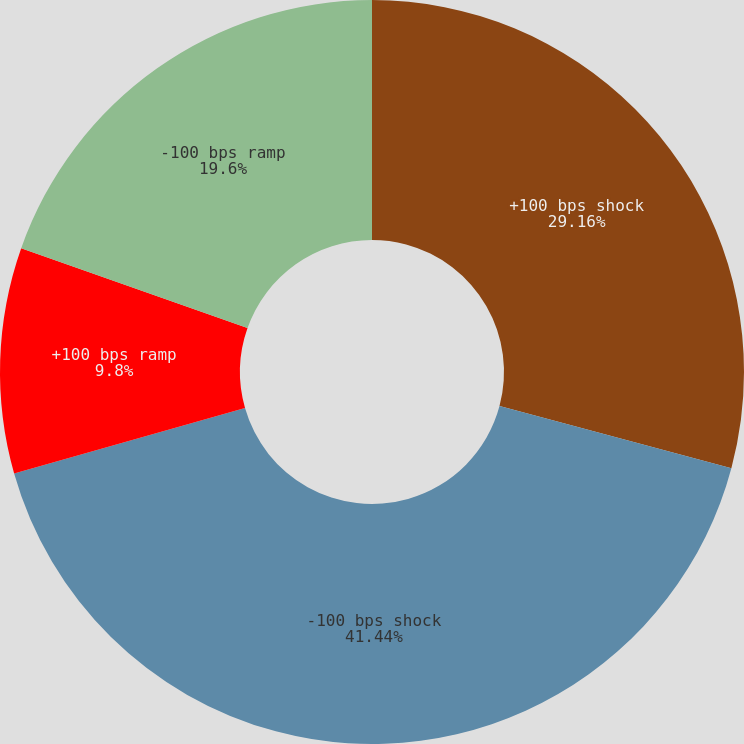Convert chart to OTSL. <chart><loc_0><loc_0><loc_500><loc_500><pie_chart><fcel>+100 bps shock<fcel>-100 bps shock<fcel>+100 bps ramp<fcel>-100 bps ramp<nl><fcel>29.16%<fcel>41.44%<fcel>9.8%<fcel>19.6%<nl></chart> 